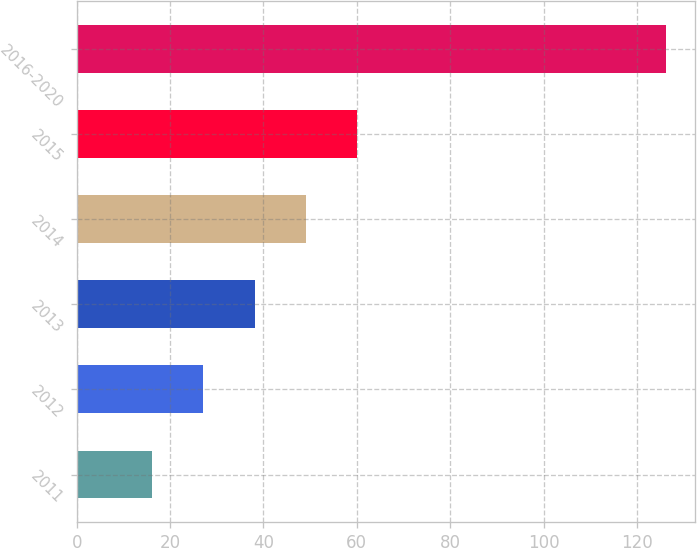<chart> <loc_0><loc_0><loc_500><loc_500><bar_chart><fcel>2011<fcel>2012<fcel>2013<fcel>2014<fcel>2015<fcel>2016-2020<nl><fcel>16.1<fcel>27.11<fcel>38.12<fcel>49.13<fcel>60.14<fcel>126.2<nl></chart> 